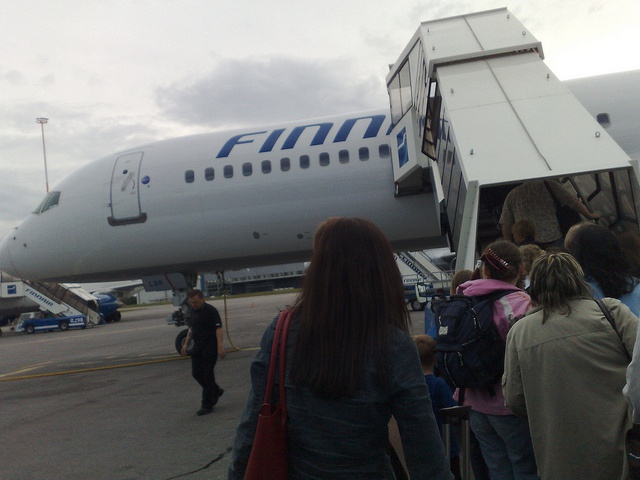Describe the objects in this image and their specific colors. I can see airplane in white, gray, darkgray, and black tones, people in white, black, maroon, and gray tones, people in white, black, and gray tones, people in white, black, gray, and purple tones, and backpack in white, black, gray, and purple tones in this image. 